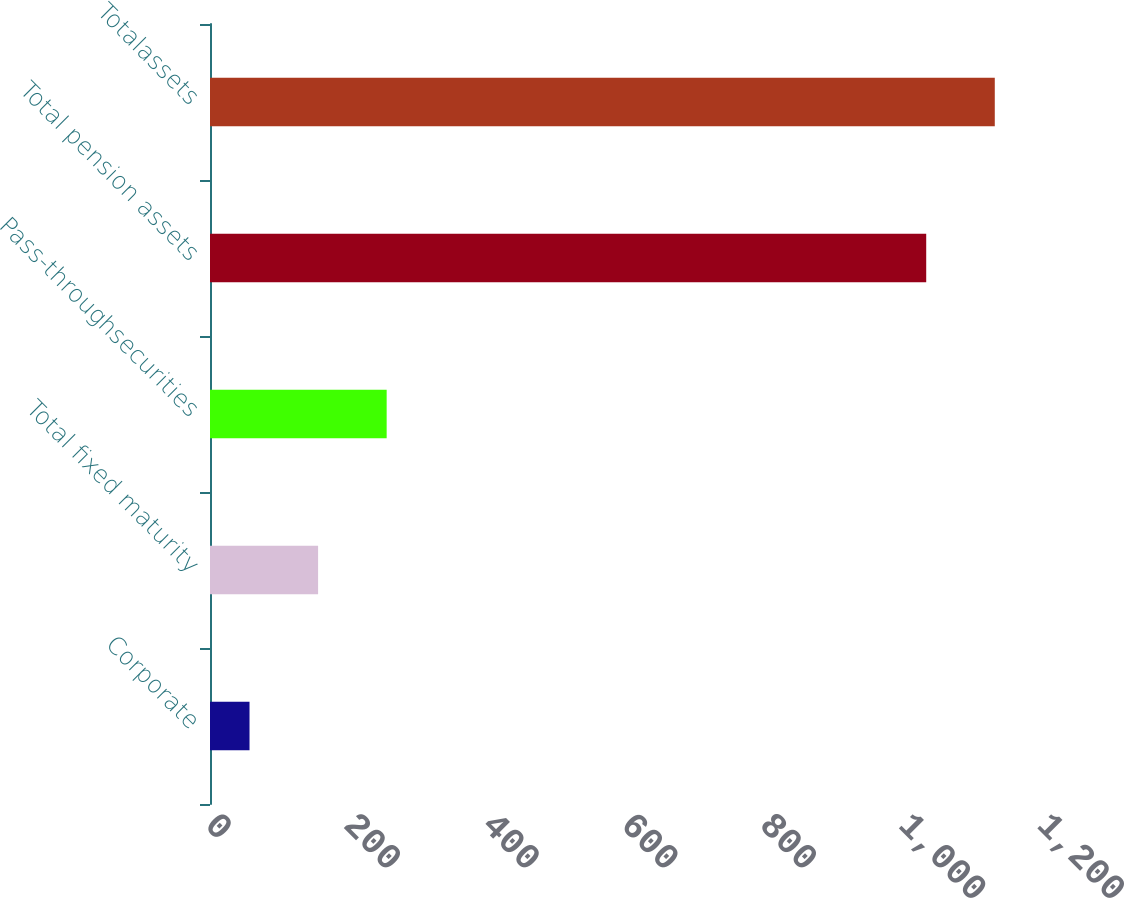Convert chart. <chart><loc_0><loc_0><loc_500><loc_500><bar_chart><fcel>Corporate<fcel>Total fixed maturity<fcel>Pass-throughsecurities<fcel>Total pension assets<fcel>Totalassets<nl><fcel>57<fcel>155.9<fcel>254.8<fcel>1033<fcel>1131.9<nl></chart> 